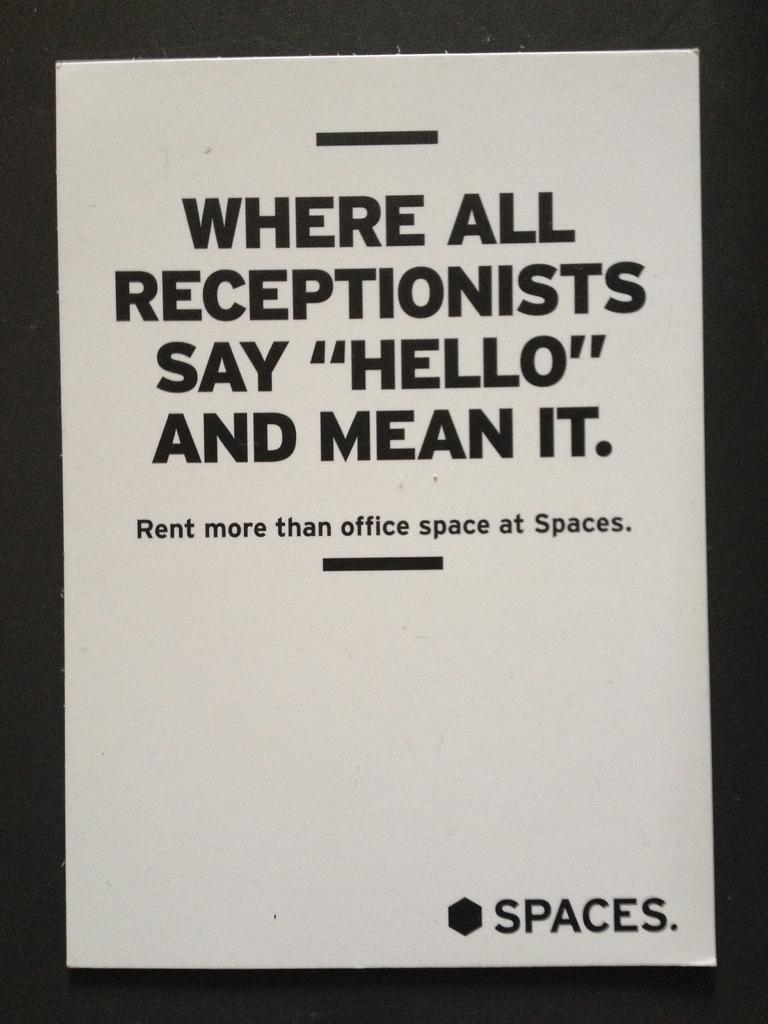<image>
Give a short and clear explanation of the subsequent image. White piece of paper that says "Spaces" on the bottom. 